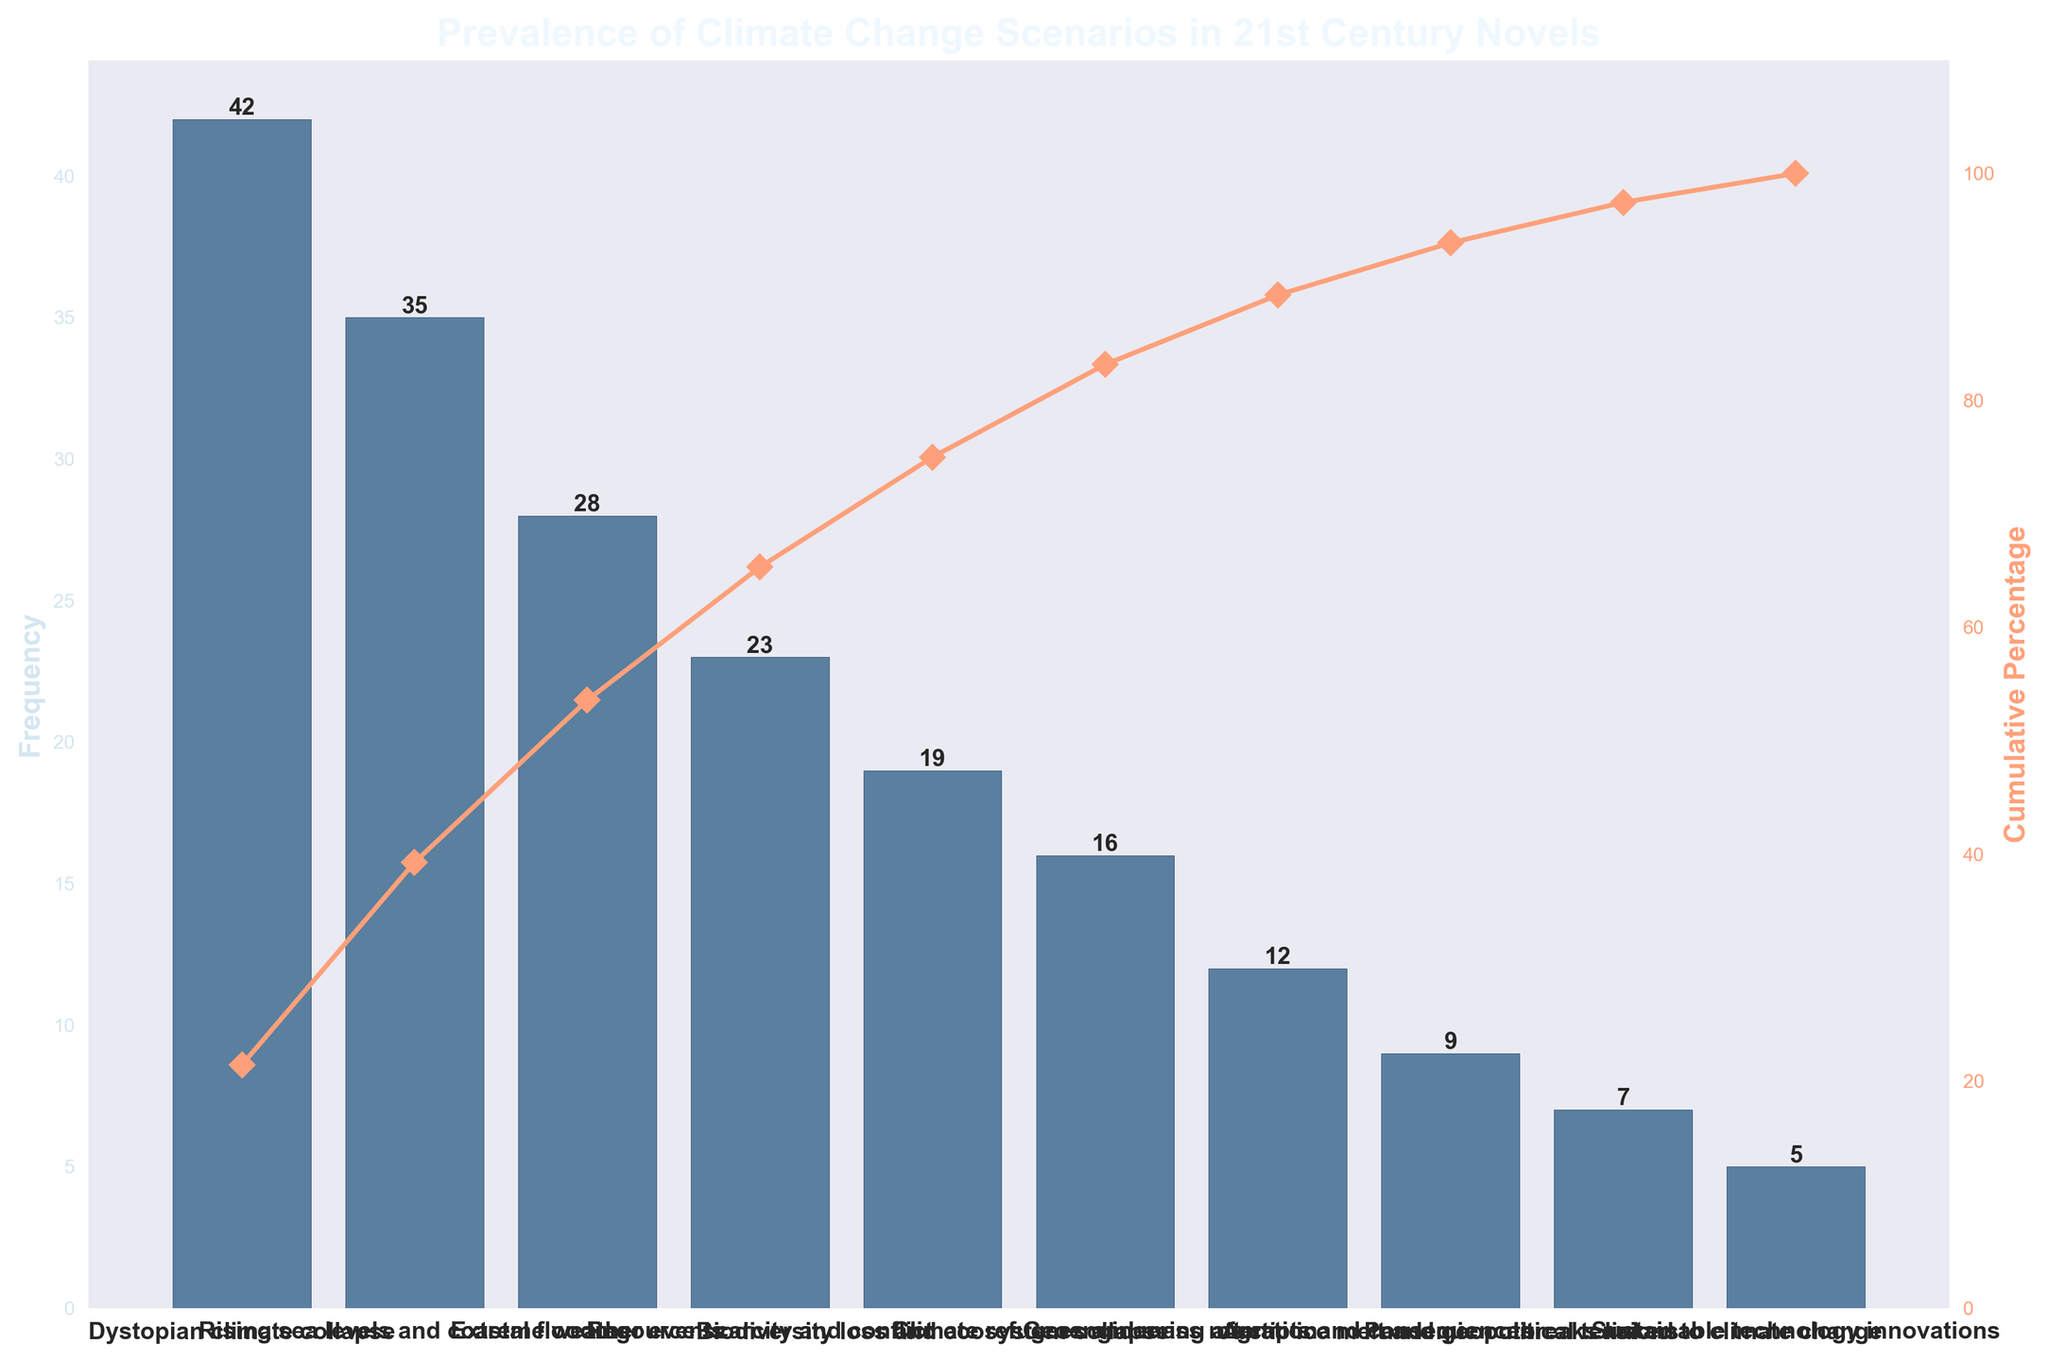what is the most prevalent climate change scenario in award-winning novels of the 21st century? The title of the chart mentions "Prevalence of Climate Change Scenarios in 21st Century Novels," and the first bar represents the most frequent scenario. The highest bar is labeled "Dystopian climate collapse", with a frequency of 42.
Answer: Dystopian climate collapse What is the total frequency of the top three climate change scenarios? The top three scenarios have frequencies of 42, 35, and 28 respectively. Summing these values: 42 + 35 + 28 = 105.
Answer: 105 Is the frequency of "Extreme weather events" higher than "Resource scarcity and conflict"? The bar representing "Extreme weather events" has a frequency of 28, whereas "Resource scarcity and conflict" has a frequency of 23. Since 28 is greater than 23, "Extreme weather events" is higher.
Answer: Yes What is the cumulative percentage after the first two categories? The frequencies of the first two categories are 42 and 35. The total is 42 + 35 = 77. The overall sum of all categories is 196. So, the cumulative percentage is (77/196)*100 ≈ 39.29%.
Answer: 39.29% Identify the scenario with the lowest frequency and state its value. The lowest bar corresponds to "Sustainable technology innovations" with a frequency value of 5.
Answer: Sustainable technology innovations, 5 How does the cumulative percentage change between "Biodiversity loss and ecosystem collapse" and "Climate refugees and mass migration"? "Biodiversity loss and ecosystem collapse" has a frequency of 19, and "Climate refugees and mass migration" has a frequency of 16. The cumulative percentage for "Biodiversity loss and ecosystem collapse" includes all previous scenarios: (42+35+28+23+19)/196 ≈ 76.53%. Adding "Climate refugees and mass migration" makes it (42+35+28+23+19+16)/196 ≈ 84.18%. The change is 84.18% - 76.53% = 7.65%.
Answer: 7.65% Which scenario marked a cumulative percentage crossing the halfway mark (over 50%)? To determine when the cumulative percentage crosses 50%, we sum the frequencies until the cumulative total surpasses 50% of 196 (which is 98). Summing 42 (21.43%), 35 (39.29%), and 28 (53.06%) tells us that "Extreme weather events" crosses the halfway mark.
Answer: Extreme weather events What is the difference in frequency between the categories "Resource scarcity and conflict" and "Geoengineering attempts and consequences"? The frequency of "Resource scarcity and conflict" is 23, and "Geoengineering attempts and consequences" is 12. The difference is 23 - 12 = 11.
Answer: 11 List the scenarios having a cumulative percentage under 90%. The cumulative percentage for the top seven scenarios are: 21.43%, 39.29%, 53.06%, 64.80%, 74.49%, 82.65%, 88.78%. All these scenarios' names are "Dystopian climate collapse," "Rising sea levels and coastal flooding," "Extreme weather events," "Resource scarcity and conflict," "Biodiversity loss and ecosystem collapse," "Climate refugees and mass migration," "Geoengineering attempts and consequences."
Answer: (Dystopian climate collapse, Rising sea levels and coastal flooding, Extreme weather events, Resource scarcity and conflict, Biodiversity loss and ecosystem collapse, Climate refugees and mass migration, Geoengineering attempts and consequences) Is the category "Arctic ice melt and geopolitical tensions" more prevalent than "Pandemic outbreaks linked to climate change"? "Arctic ice melt and geopolitical tensions" has a frequency of 9, while "Pandemic outbreaks linked to climate change" has a frequency of 7. Since 9 is greater than 7, it is more prevalent.
Answer: Yes 